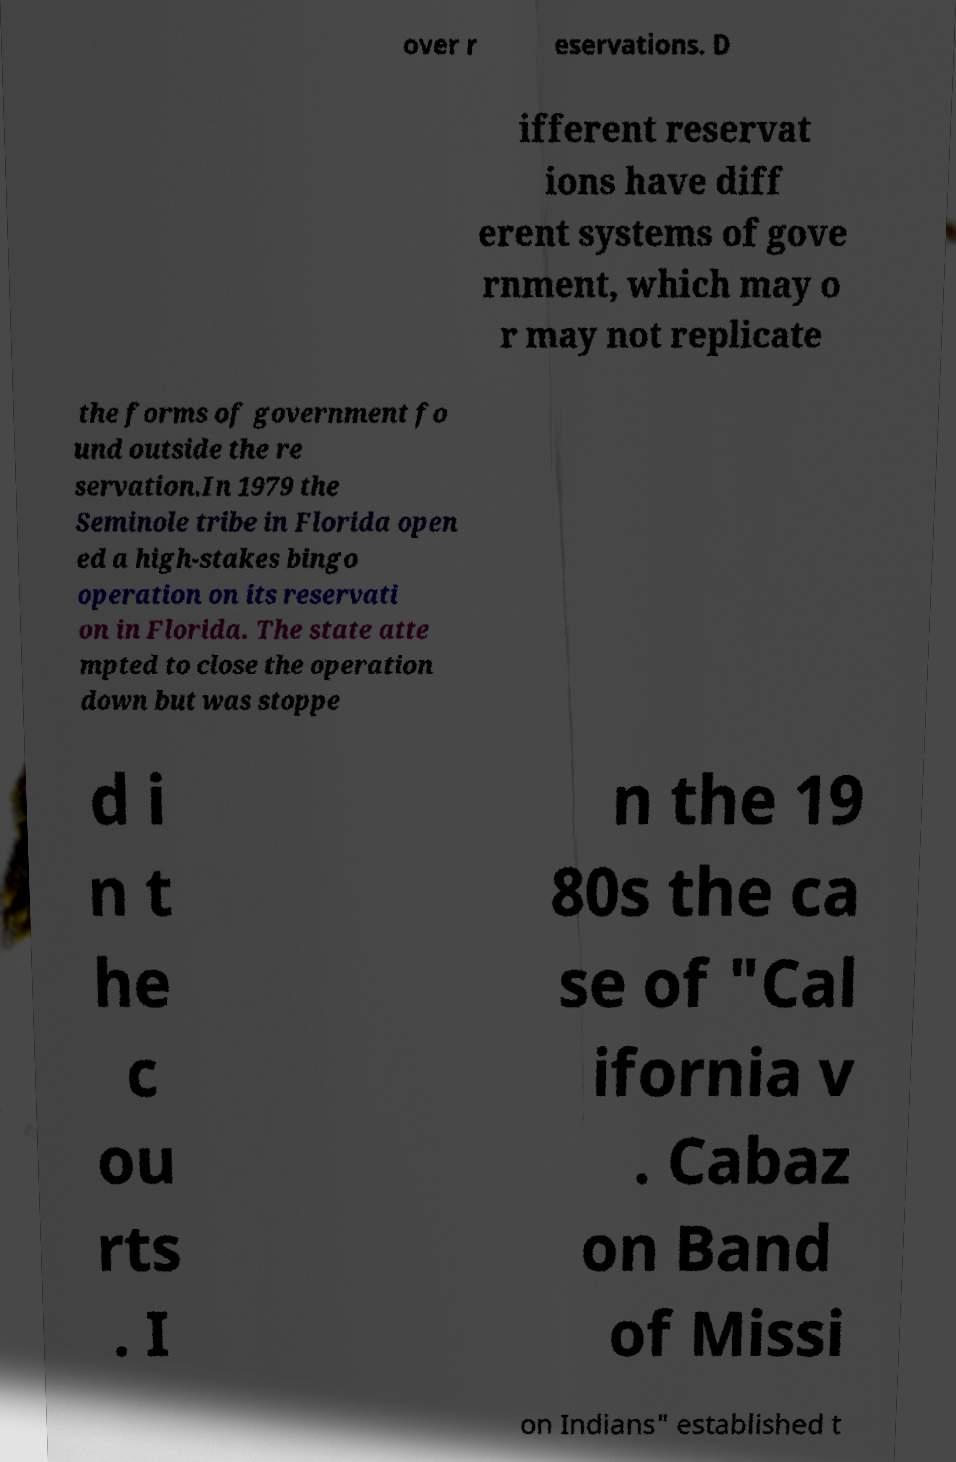Could you assist in decoding the text presented in this image and type it out clearly? over r eservations. D ifferent reservat ions have diff erent systems of gove rnment, which may o r may not replicate the forms of government fo und outside the re servation.In 1979 the Seminole tribe in Florida open ed a high-stakes bingo operation on its reservati on in Florida. The state atte mpted to close the operation down but was stoppe d i n t he c ou rts . I n the 19 80s the ca se of "Cal ifornia v . Cabaz on Band of Missi on Indians" established t 